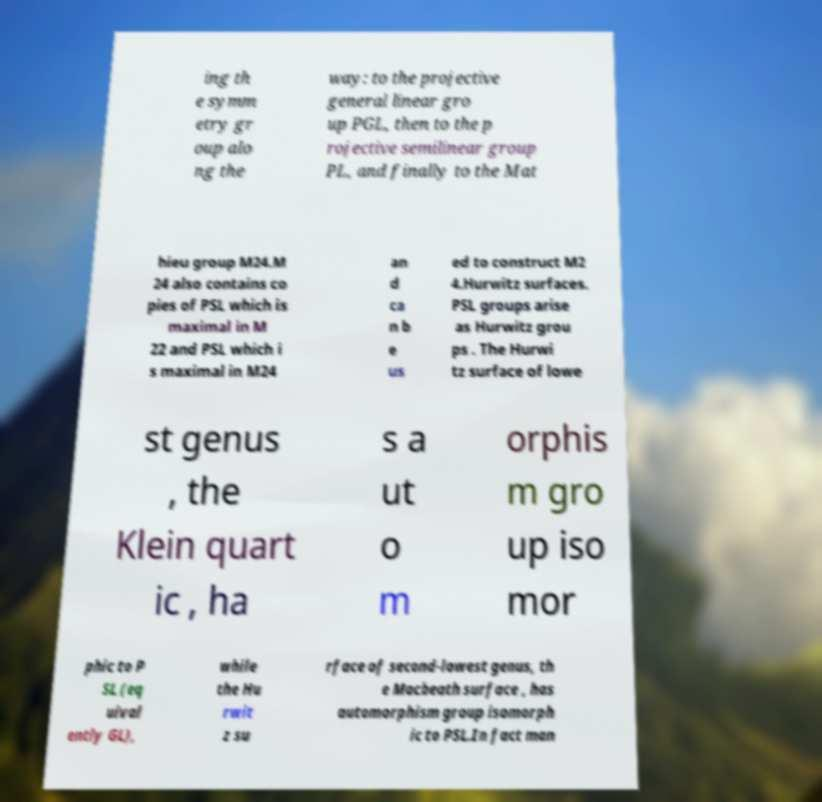What messages or text are displayed in this image? I need them in a readable, typed format. ing th e symm etry gr oup alo ng the way: to the projective general linear gro up PGL, then to the p rojective semilinear group PL, and finally to the Mat hieu group M24.M 24 also contains co pies of PSL which is maximal in M 22 and PSL which i s maximal in M24 an d ca n b e us ed to construct M2 4.Hurwitz surfaces. PSL groups arise as Hurwitz grou ps . The Hurwi tz surface of lowe st genus , the Klein quart ic , ha s a ut o m orphis m gro up iso mor phic to P SL (eq uival ently GL), while the Hu rwit z su rface of second-lowest genus, th e Macbeath surface , has automorphism group isomorph ic to PSL.In fact man 